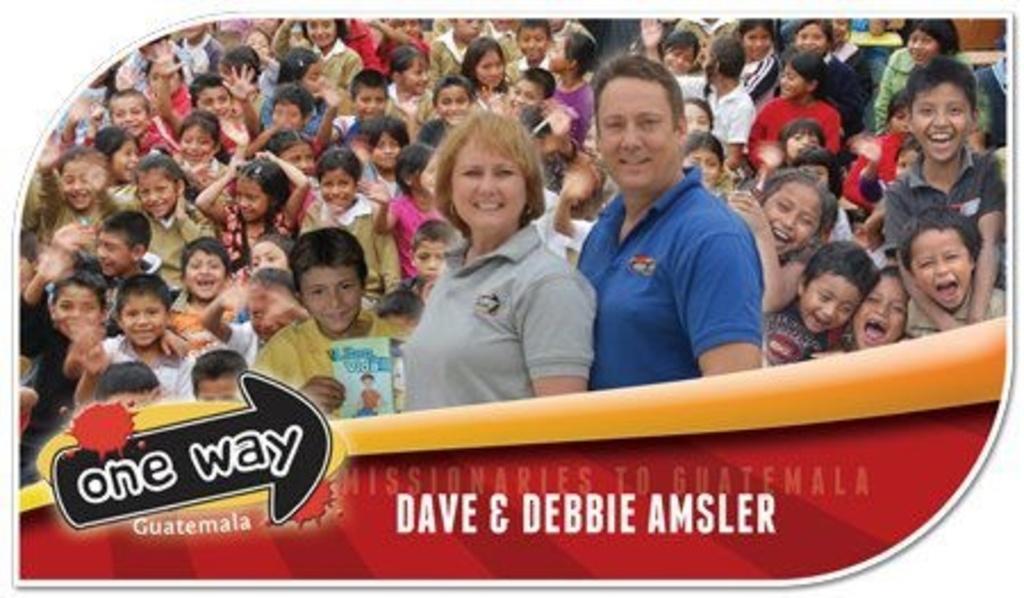In one or two sentences, can you explain what this image depicts? In the center of the image we can see a poster. On the poster, we can see a few people are smiling. Among them, we can see one person is holding some object. And we can see some text on the poster. 